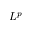Convert formula to latex. <formula><loc_0><loc_0><loc_500><loc_500>L ^ { p }</formula> 